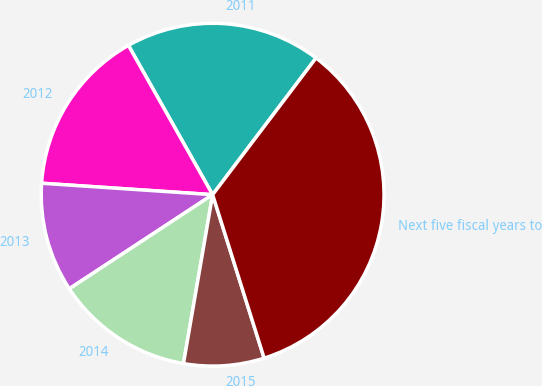Convert chart. <chart><loc_0><loc_0><loc_500><loc_500><pie_chart><fcel>2011<fcel>2012<fcel>2013<fcel>2014<fcel>2015<fcel>Next five fiscal years to<nl><fcel>18.48%<fcel>15.76%<fcel>10.31%<fcel>13.03%<fcel>7.58%<fcel>34.83%<nl></chart> 